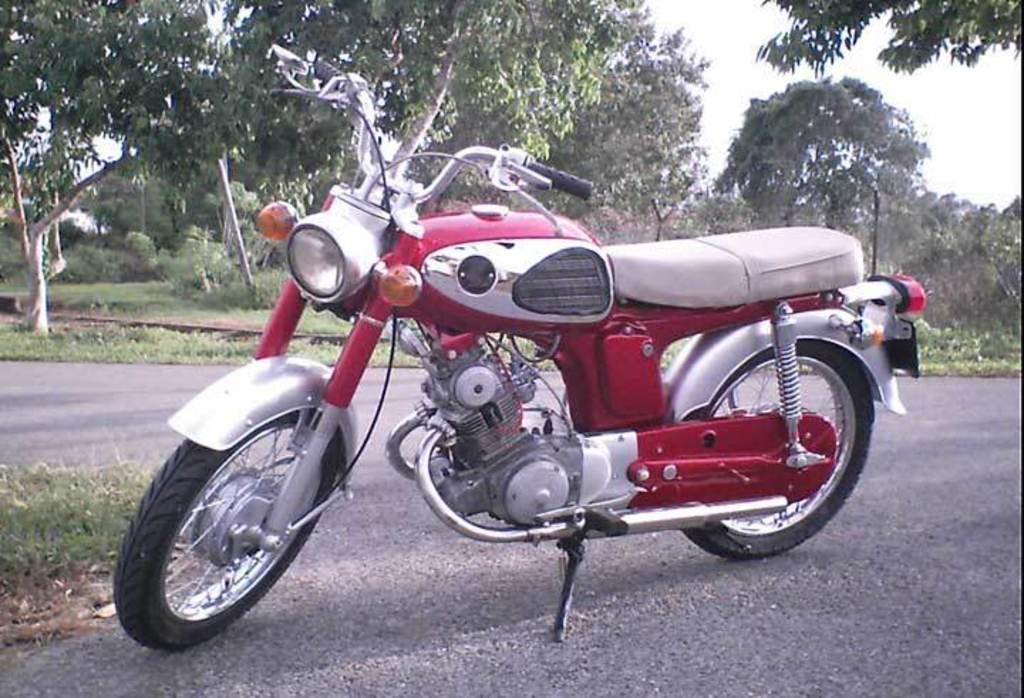Describe this image in one or two sentences. In this image I can see the motorbike on the road. In the background I can see many trees and the sky. 